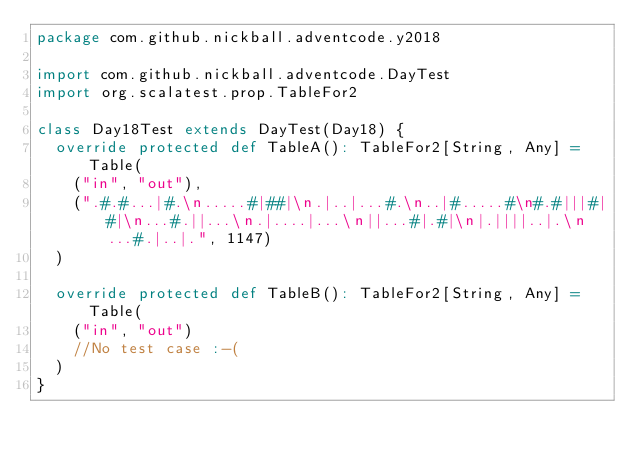<code> <loc_0><loc_0><loc_500><loc_500><_Scala_>package com.github.nickball.adventcode.y2018

import com.github.nickball.adventcode.DayTest
import org.scalatest.prop.TableFor2

class Day18Test extends DayTest(Day18) {
  override protected def TableA(): TableFor2[String, Any] = Table(
    ("in", "out"),
    (".#.#...|#.\n.....#|##|\n.|..|...#.\n..|#.....#\n#.#|||#|#|\n...#.||...\n.|....|...\n||...#|.#|\n|.||||..|.\n...#.|..|.", 1147)
  )

  override protected def TableB(): TableFor2[String, Any] = Table(
    ("in", "out")
    //No test case :-(
  )
}
</code> 